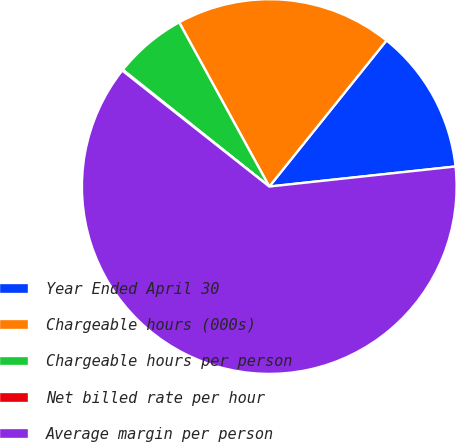<chart> <loc_0><loc_0><loc_500><loc_500><pie_chart><fcel>Year Ended April 30<fcel>Chargeable hours (000s)<fcel>Chargeable hours per person<fcel>Net billed rate per hour<fcel>Average margin per person<nl><fcel>12.53%<fcel>18.75%<fcel>6.3%<fcel>0.08%<fcel>62.34%<nl></chart> 